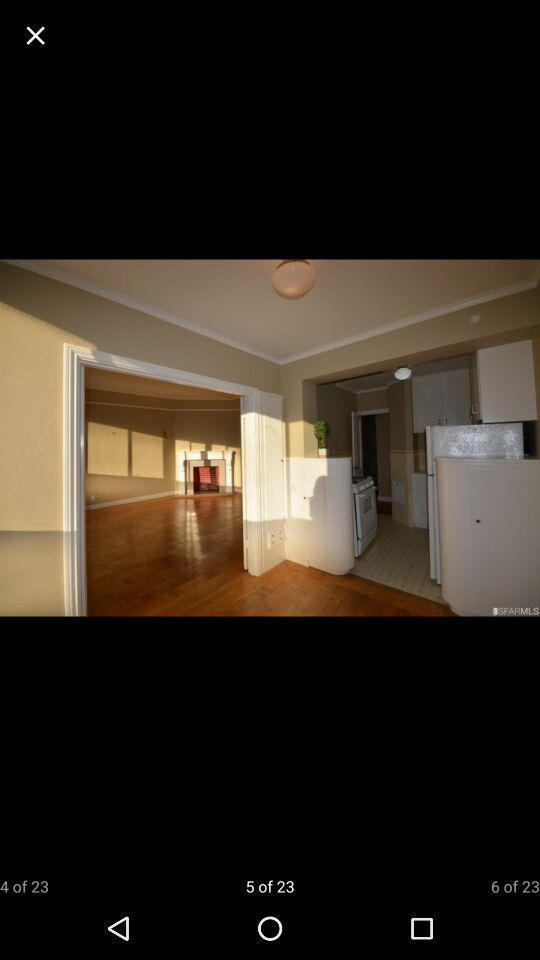Tell me about the visual elements in this screen capture. Page showing an image of inner side of the house. 